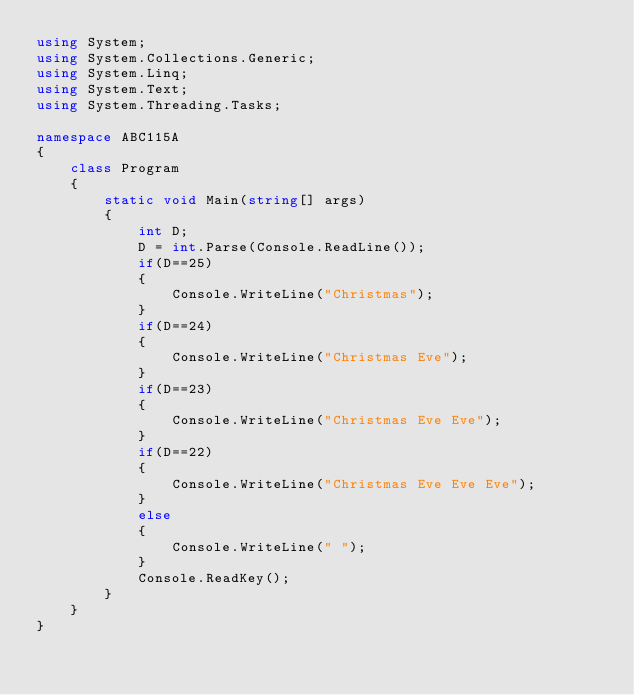<code> <loc_0><loc_0><loc_500><loc_500><_C#_>using System;
using System.Collections.Generic;
using System.Linq;
using System.Text;
using System.Threading.Tasks;

namespace ABC115A
{
    class Program
    {
        static void Main(string[] args)
        {
            int D;
            D = int.Parse(Console.ReadLine());
            if(D==25)
            {
                Console.WriteLine("Christmas");
            }
            if(D==24)
            {
                Console.WriteLine("Christmas Eve");
            }
            if(D==23)
            {
                Console.WriteLine("Christmas Eve Eve");
            }
            if(D==22)
            {
                Console.WriteLine("Christmas Eve Eve Eve");
            }
            else
            {
                Console.WriteLine(" ");
            }
            Console.ReadKey();
        }
    }
}</code> 